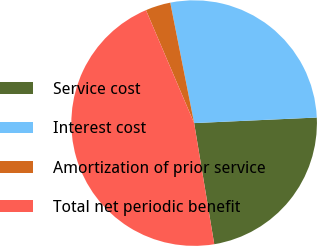Convert chart to OTSL. <chart><loc_0><loc_0><loc_500><loc_500><pie_chart><fcel>Service cost<fcel>Interest cost<fcel>Amortization of prior service<fcel>Total net periodic benefit<nl><fcel>23.1%<fcel>27.39%<fcel>3.3%<fcel>46.2%<nl></chart> 